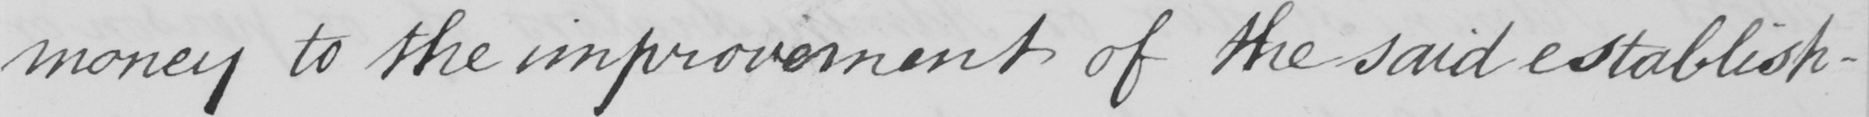Please transcribe the handwritten text in this image. money to the improvement of the said establish- 